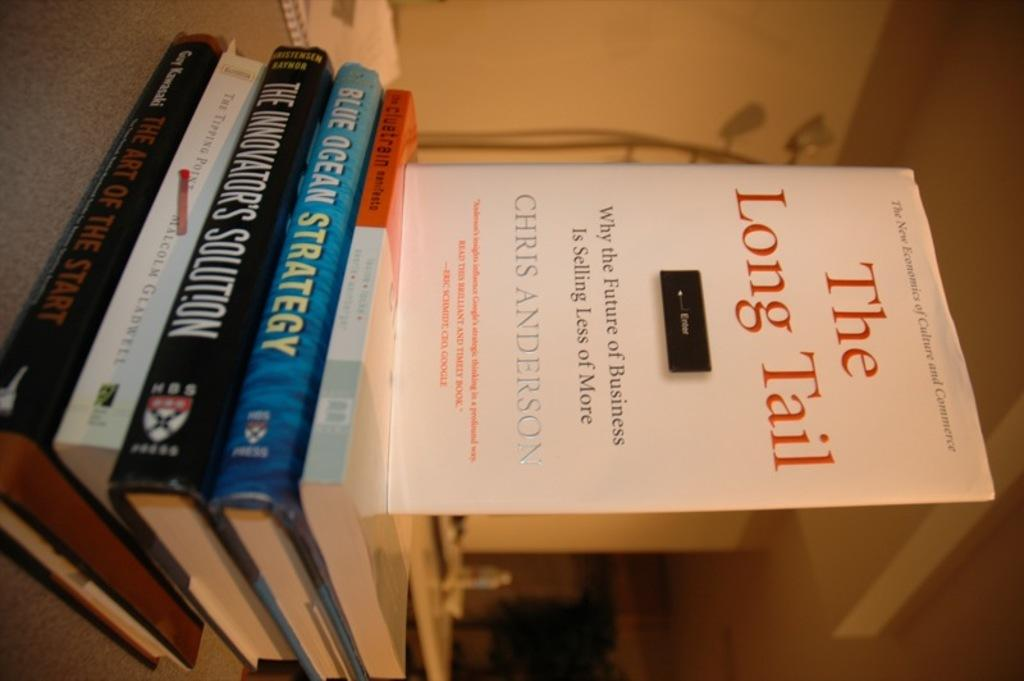<image>
Share a concise interpretation of the image provided. A sideways picture of some books with the top book reading The Long Tail. 